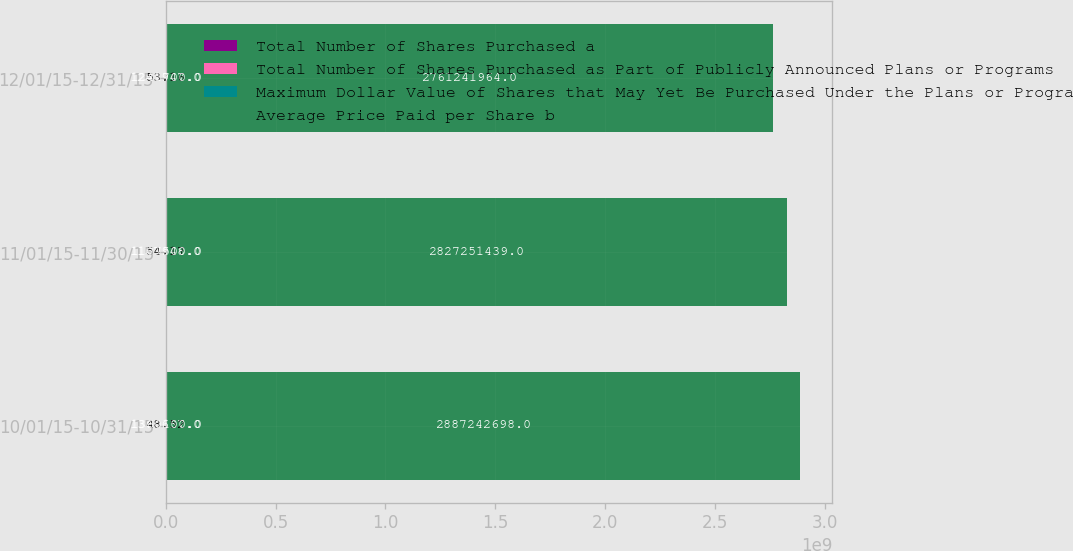Convert chart. <chart><loc_0><loc_0><loc_500><loc_500><stacked_bar_chart><ecel><fcel>10/01/15-10/31/15<fcel>11/01/15-11/30/15<fcel>12/01/15-12/31/15<nl><fcel>Total Number of Shares Purchased a<fcel>1.36364e+06<fcel>1.10795e+06<fcel>1.24195e+06<nl><fcel>Total Number of Shares Purchased as Part of Publicly Announced Plans or Programs<fcel>48.52<fcel>54.17<fcel>53.16<nl><fcel>Maximum Dollar Value of Shares that May Yet Be Purchased Under the Plans or Programs c<fcel>1.3601e+06<fcel>1.1075e+06<fcel>1.2417e+06<nl><fcel>Average Price Paid per Share b<fcel>2.88724e+09<fcel>2.82725e+09<fcel>2.76124e+09<nl></chart> 